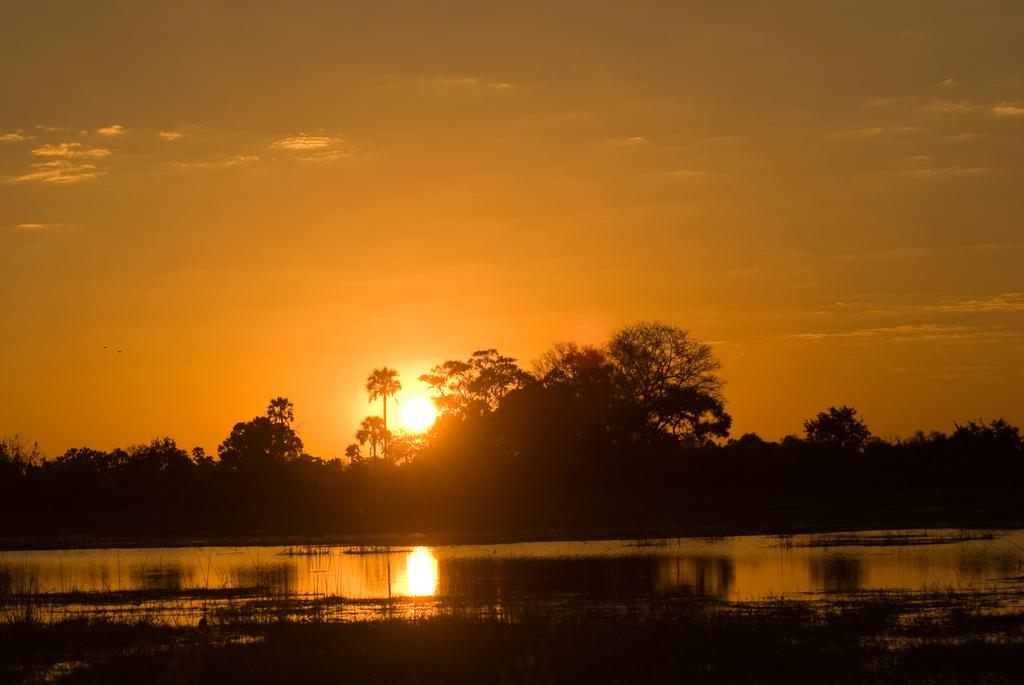What is the primary element visible in the image? There is a water surface in the image. What can be seen in the background of the image? There are trees and the sky visible in the background of the image. Can the sun be seen in the image? Yes, the sun is observable in the sky. What grade of nut is being used in the image? There is no nut present in the image, so it is not possible to determine the grade of any nut. 